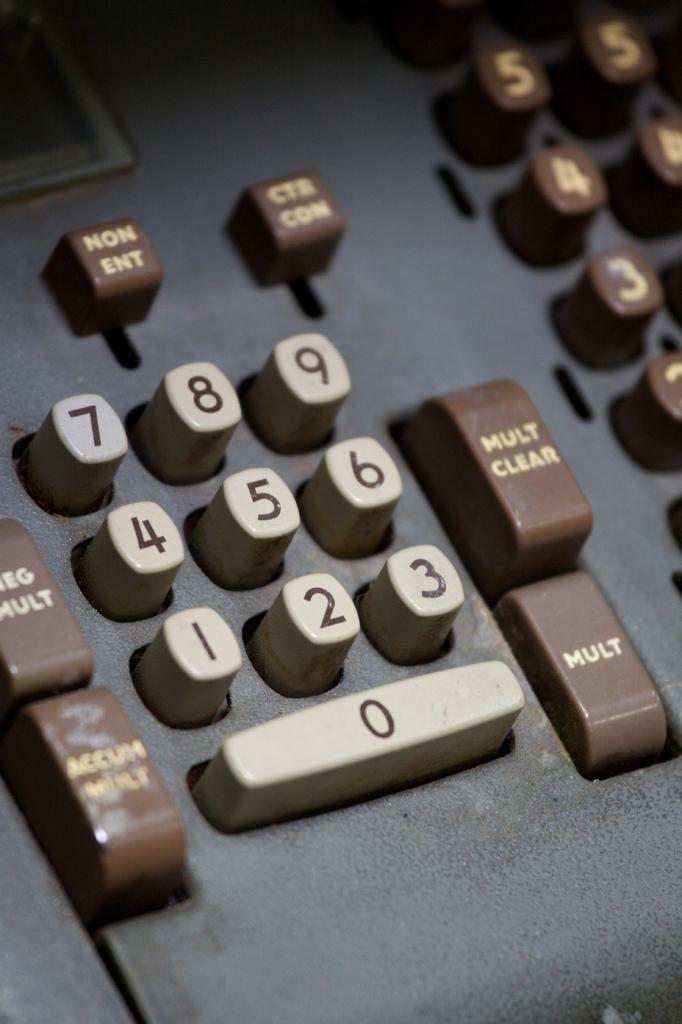<image>
Provide a brief description of the given image. A old adding machining is shown with white and brown keys and one key has MULT on it. 